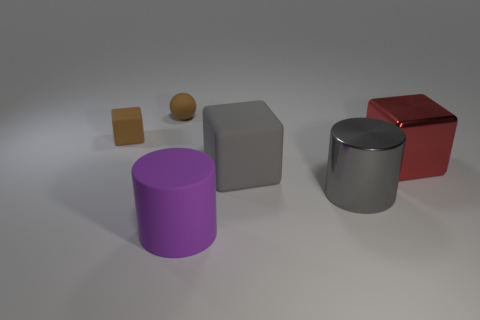Add 4 small blue metal things. How many objects exist? 10 Subtract all cylinders. How many objects are left? 4 Add 4 big matte objects. How many big matte objects exist? 6 Subtract 1 purple cylinders. How many objects are left? 5 Subtract all tiny metal cylinders. Subtract all purple cylinders. How many objects are left? 5 Add 6 big purple matte cylinders. How many big purple matte cylinders are left? 7 